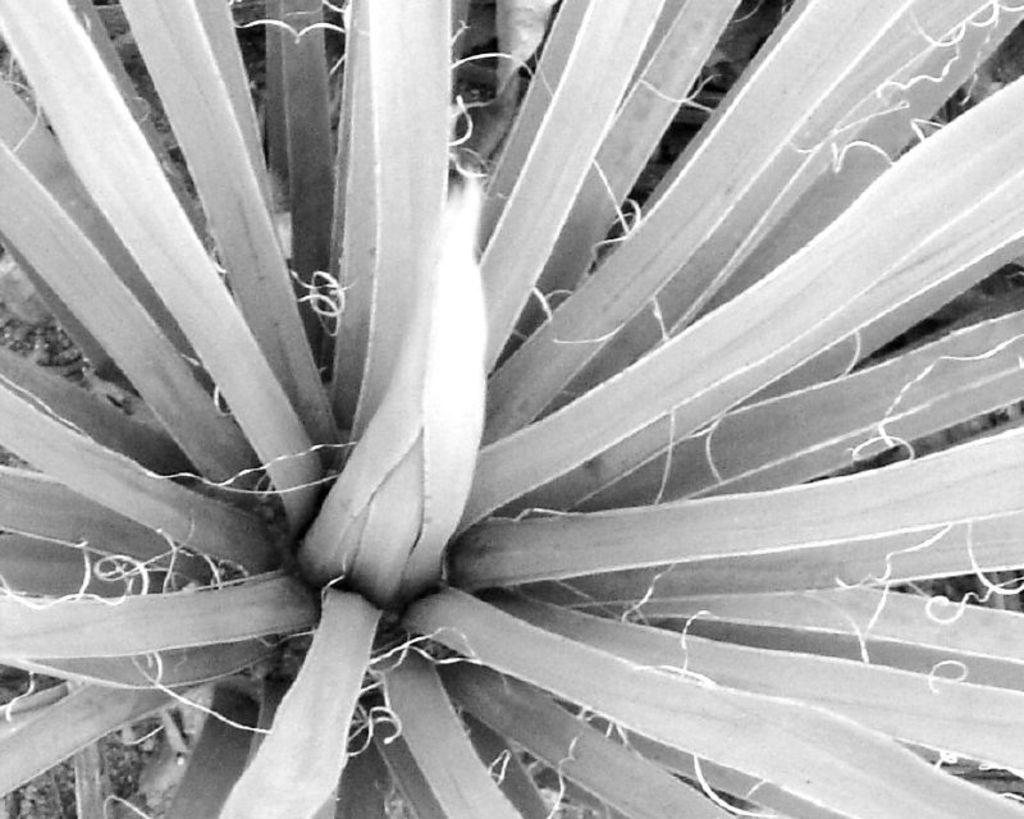What is present in the image? There is a plant in the image. Where is the plant located? The plant is on the ground. How many sisters are depicted interacting with the plant in the image? There are no sisters present in the image; it only features a plant on the ground. What type of rifle can be seen leaning against the plant in the image? There is no rifle present in the image; it only features a plant on the ground. 